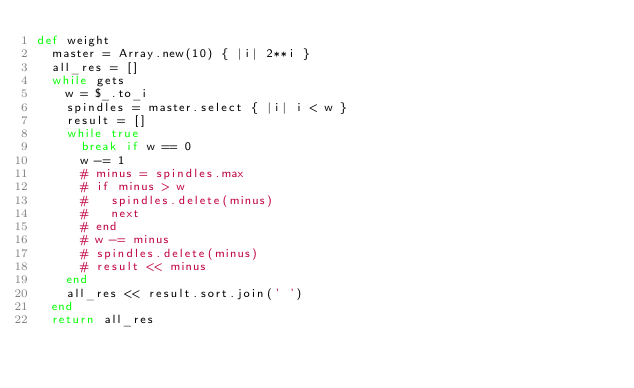<code> <loc_0><loc_0><loc_500><loc_500><_Ruby_>def weight
  master = Array.new(10) { |i| 2**i }
  all_res = []
  while gets
    w = $_.to_i
    spindles = master.select { |i| i < w }
    result = []
    while true
      break if w == 0
      w -= 1
      # minus = spindles.max
      # if minus > w
      #   spindles.delete(minus)
      #   next
      # end
      # w -= minus
      # spindles.delete(minus)
      # result << minus
    end
    all_res << result.sort.join(' ')
  end
  return all_res</code> 